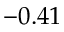<formula> <loc_0><loc_0><loc_500><loc_500>- 0 . 4 1</formula> 